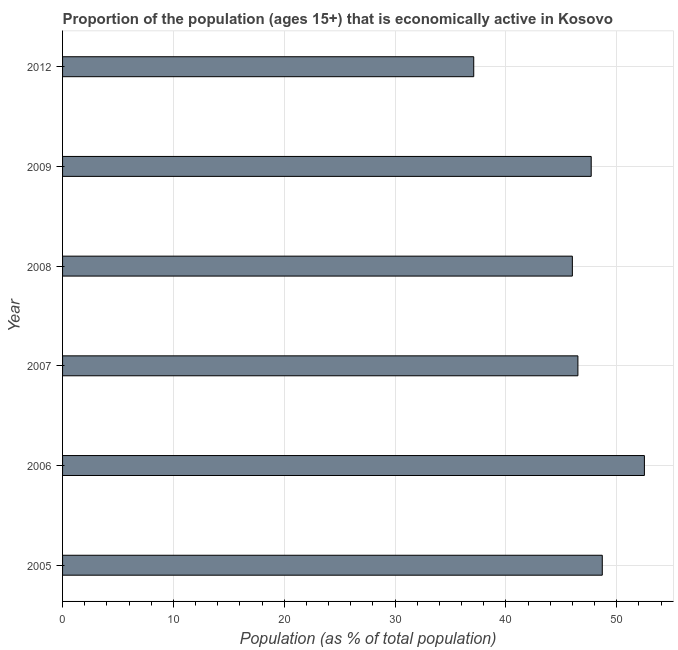Does the graph contain any zero values?
Offer a very short reply. No. What is the title of the graph?
Give a very brief answer. Proportion of the population (ages 15+) that is economically active in Kosovo. What is the label or title of the X-axis?
Make the answer very short. Population (as % of total population). What is the label or title of the Y-axis?
Keep it short and to the point. Year. What is the percentage of economically active population in 2007?
Provide a succinct answer. 46.5. Across all years, what is the maximum percentage of economically active population?
Your response must be concise. 52.5. Across all years, what is the minimum percentage of economically active population?
Give a very brief answer. 37.1. In which year was the percentage of economically active population minimum?
Offer a terse response. 2012. What is the sum of the percentage of economically active population?
Provide a short and direct response. 278.5. What is the average percentage of economically active population per year?
Offer a terse response. 46.42. What is the median percentage of economically active population?
Your response must be concise. 47.1. What is the ratio of the percentage of economically active population in 2007 to that in 2008?
Give a very brief answer. 1.01. Is the percentage of economically active population in 2005 less than that in 2007?
Provide a succinct answer. No. What is the difference between the highest and the second highest percentage of economically active population?
Make the answer very short. 3.8. In how many years, is the percentage of economically active population greater than the average percentage of economically active population taken over all years?
Provide a short and direct response. 4. How many bars are there?
Give a very brief answer. 6. What is the difference between two consecutive major ticks on the X-axis?
Give a very brief answer. 10. What is the Population (as % of total population) of 2005?
Make the answer very short. 48.7. What is the Population (as % of total population) of 2006?
Give a very brief answer. 52.5. What is the Population (as % of total population) of 2007?
Offer a very short reply. 46.5. What is the Population (as % of total population) of 2008?
Make the answer very short. 46. What is the Population (as % of total population) in 2009?
Provide a succinct answer. 47.7. What is the Population (as % of total population) in 2012?
Your response must be concise. 37.1. What is the difference between the Population (as % of total population) in 2005 and 2008?
Offer a very short reply. 2.7. What is the difference between the Population (as % of total population) in 2005 and 2009?
Give a very brief answer. 1. What is the difference between the Population (as % of total population) in 2005 and 2012?
Your response must be concise. 11.6. What is the difference between the Population (as % of total population) in 2006 and 2007?
Provide a short and direct response. 6. What is the difference between the Population (as % of total population) in 2007 and 2009?
Your response must be concise. -1.2. What is the difference between the Population (as % of total population) in 2008 and 2012?
Give a very brief answer. 8.9. What is the difference between the Population (as % of total population) in 2009 and 2012?
Keep it short and to the point. 10.6. What is the ratio of the Population (as % of total population) in 2005 to that in 2006?
Provide a short and direct response. 0.93. What is the ratio of the Population (as % of total population) in 2005 to that in 2007?
Provide a succinct answer. 1.05. What is the ratio of the Population (as % of total population) in 2005 to that in 2008?
Your answer should be very brief. 1.06. What is the ratio of the Population (as % of total population) in 2005 to that in 2012?
Provide a short and direct response. 1.31. What is the ratio of the Population (as % of total population) in 2006 to that in 2007?
Give a very brief answer. 1.13. What is the ratio of the Population (as % of total population) in 2006 to that in 2008?
Provide a short and direct response. 1.14. What is the ratio of the Population (as % of total population) in 2006 to that in 2009?
Make the answer very short. 1.1. What is the ratio of the Population (as % of total population) in 2006 to that in 2012?
Make the answer very short. 1.42. What is the ratio of the Population (as % of total population) in 2007 to that in 2009?
Offer a very short reply. 0.97. What is the ratio of the Population (as % of total population) in 2007 to that in 2012?
Your answer should be very brief. 1.25. What is the ratio of the Population (as % of total population) in 2008 to that in 2012?
Your answer should be very brief. 1.24. What is the ratio of the Population (as % of total population) in 2009 to that in 2012?
Provide a short and direct response. 1.29. 